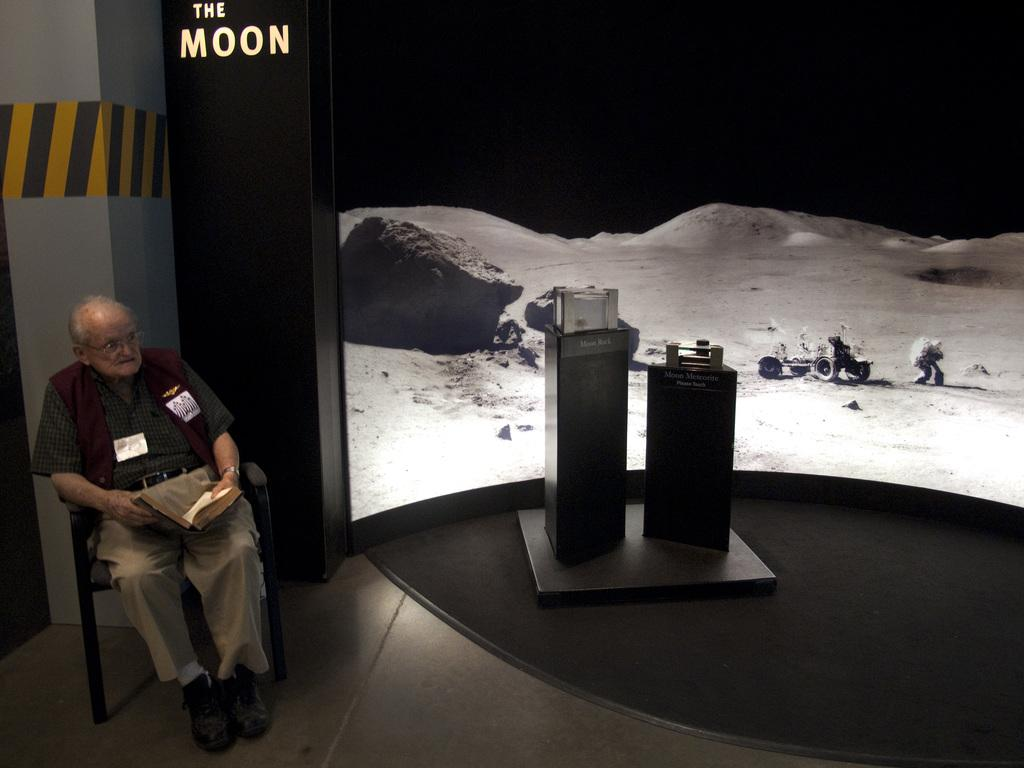What is the man in the image doing? The man is sitting on a chair in the image. What is the man holding in the image? The man is holding a book. What can be seen on stands in the image? There are objects on stands in the image. What is written or displayed on the wall in the image? There is text on the wall in the image. What can be seen in the background of the image? There is a screen visible in the background of the image. What type of beef is being served on the plate in the image? There is no plate or beef present in the image. What is the man hoping for in the image? The image does not provide any information about the man's hopes or desires. 